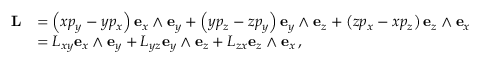<formula> <loc_0><loc_0><loc_500><loc_500>{ \begin{array} { r l } { L } & { = \left ( x p _ { y } - y p _ { x } \right ) e _ { x } \wedge e _ { y } + \left ( y p _ { z } - z p _ { y } \right ) e _ { y } \wedge e _ { z } + \left ( z p _ { x } - x p _ { z } \right ) e _ { z } \wedge e _ { x } } \\ & { = L _ { x y } e _ { x } \wedge e _ { y } + L _ { y z } e _ { y } \wedge e _ { z } + L _ { z x } e _ { z } \wedge e _ { x } \, , } \end{array} }</formula> 